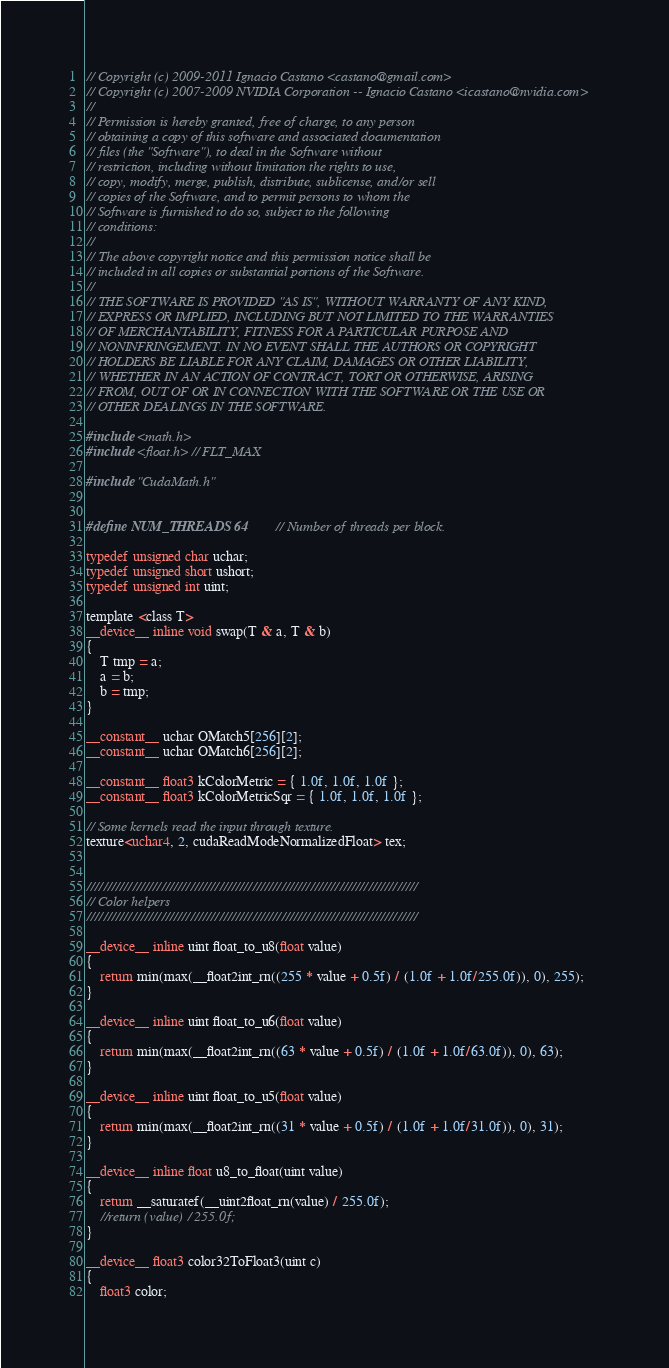<code> <loc_0><loc_0><loc_500><loc_500><_Cuda_>// Copyright (c) 2009-2011 Ignacio Castano <castano@gmail.com>
// Copyright (c) 2007-2009 NVIDIA Corporation -- Ignacio Castano <icastano@nvidia.com>
// 
// Permission is hereby granted, free of charge, to any person
// obtaining a copy of this software and associated documentation
// files (the "Software"), to deal in the Software without
// restriction, including without limitation the rights to use,
// copy, modify, merge, publish, distribute, sublicense, and/or sell
// copies of the Software, and to permit persons to whom the
// Software is furnished to do so, subject to the following
// conditions:
// 
// The above copyright notice and this permission notice shall be
// included in all copies or substantial portions of the Software.
// 
// THE SOFTWARE IS PROVIDED "AS IS", WITHOUT WARRANTY OF ANY KIND,
// EXPRESS OR IMPLIED, INCLUDING BUT NOT LIMITED TO THE WARRANTIES
// OF MERCHANTABILITY, FITNESS FOR A PARTICULAR PURPOSE AND
// NONINFRINGEMENT. IN NO EVENT SHALL THE AUTHORS OR COPYRIGHT
// HOLDERS BE LIABLE FOR ANY CLAIM, DAMAGES OR OTHER LIABILITY,
// WHETHER IN AN ACTION OF CONTRACT, TORT OR OTHERWISE, ARISING
// FROM, OUT OF OR IN CONNECTION WITH THE SOFTWARE OR THE USE OR
// OTHER DEALINGS IN THE SOFTWARE.

#include <math.h>
#include <float.h> // FLT_MAX

#include "CudaMath.h"


#define NUM_THREADS 64		// Number of threads per block.

typedef unsigned char uchar;
typedef unsigned short ushort;
typedef unsigned int uint;

template <class T> 
__device__ inline void swap(T & a, T & b)
{
    T tmp = a;
    a = b;
    b = tmp;
}

__constant__ uchar OMatch5[256][2];
__constant__ uchar OMatch6[256][2];

__constant__ float3 kColorMetric = { 1.0f, 1.0f, 1.0f };
__constant__ float3 kColorMetricSqr = { 1.0f, 1.0f, 1.0f };

// Some kernels read the input through texture.
texture<uchar4, 2, cudaReadModeNormalizedFloat> tex;


////////////////////////////////////////////////////////////////////////////////
// Color helpers
////////////////////////////////////////////////////////////////////////////////

__device__ inline uint float_to_u8(float value)
{
    return min(max(__float2int_rn((255 * value + 0.5f) / (1.0f + 1.0f/255.0f)), 0), 255);
}

__device__ inline uint float_to_u6(float value)
{
    return min(max(__float2int_rn((63 * value + 0.5f) / (1.0f + 1.0f/63.0f)), 0), 63);
}

__device__ inline uint float_to_u5(float value)
{
    return min(max(__float2int_rn((31 * value + 0.5f) / (1.0f + 1.0f/31.0f)), 0), 31);
}

__device__ inline float u8_to_float(uint value)
{
    return __saturatef(__uint2float_rn(value) / 255.0f);
    //return (value) / 255.0f;
}

__device__ float3 color32ToFloat3(uint c)
{
    float3 color;</code> 